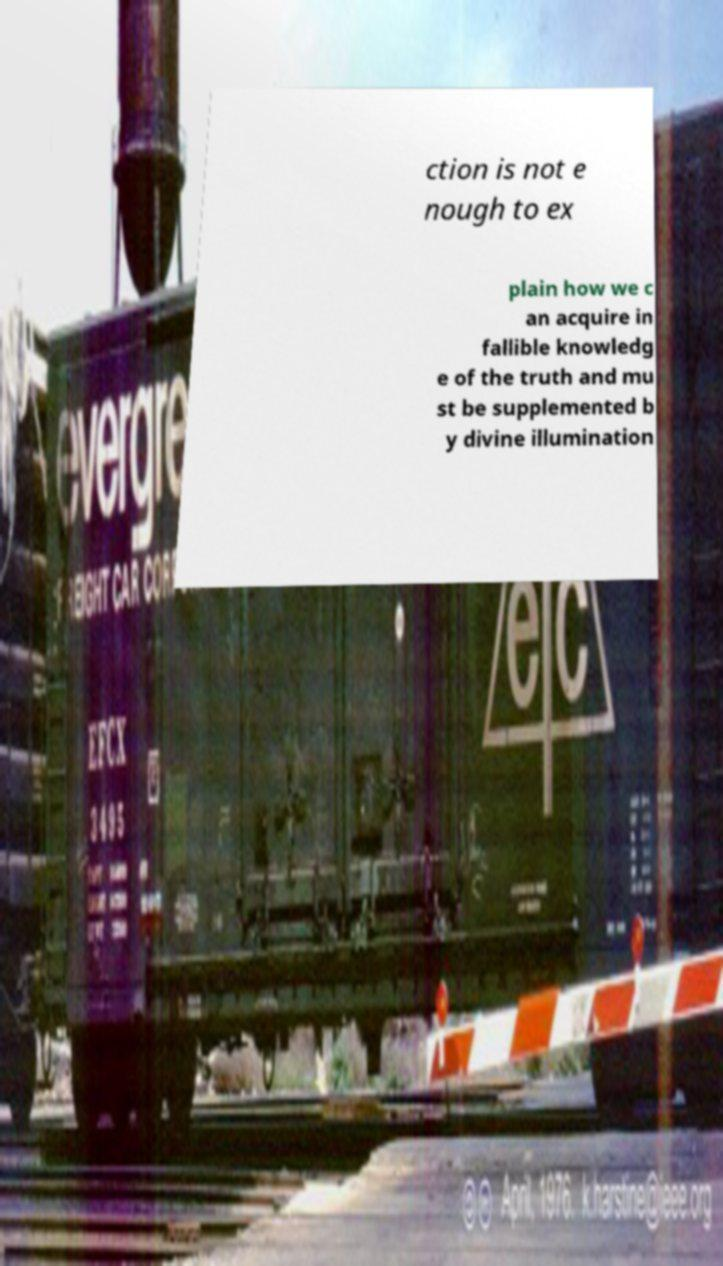What messages or text are displayed in this image? I need them in a readable, typed format. ction is not e nough to ex plain how we c an acquire in fallible knowledg e of the truth and mu st be supplemented b y divine illumination 